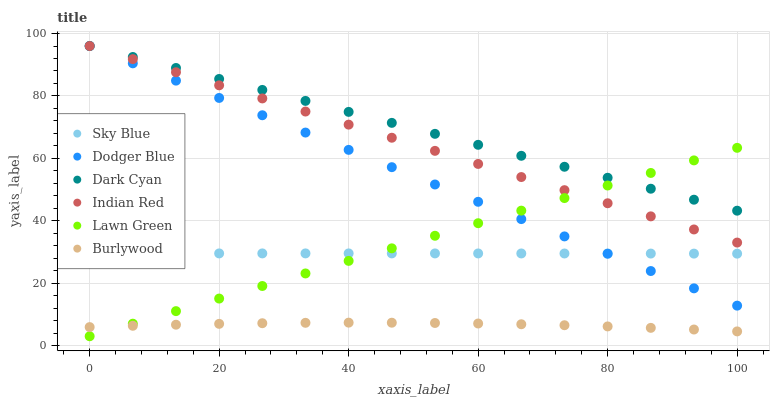Does Burlywood have the minimum area under the curve?
Answer yes or no. Yes. Does Dark Cyan have the maximum area under the curve?
Answer yes or no. Yes. Does Dodger Blue have the minimum area under the curve?
Answer yes or no. No. Does Dodger Blue have the maximum area under the curve?
Answer yes or no. No. Is Lawn Green the smoothest?
Answer yes or no. Yes. Is Burlywood the roughest?
Answer yes or no. Yes. Is Dodger Blue the smoothest?
Answer yes or no. No. Is Dodger Blue the roughest?
Answer yes or no. No. Does Lawn Green have the lowest value?
Answer yes or no. Yes. Does Burlywood have the lowest value?
Answer yes or no. No. Does Dark Cyan have the highest value?
Answer yes or no. Yes. Does Burlywood have the highest value?
Answer yes or no. No. Is Sky Blue less than Dark Cyan?
Answer yes or no. Yes. Is Dark Cyan greater than Burlywood?
Answer yes or no. Yes. Does Dodger Blue intersect Dark Cyan?
Answer yes or no. Yes. Is Dodger Blue less than Dark Cyan?
Answer yes or no. No. Is Dodger Blue greater than Dark Cyan?
Answer yes or no. No. Does Sky Blue intersect Dark Cyan?
Answer yes or no. No. 